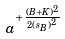Convert formula to latex. <formula><loc_0><loc_0><loc_500><loc_500>a ^ { + \frac { ( B + K ) ^ { 2 } } { 2 { ( s _ { B } ) } ^ { 2 } } }</formula> 